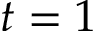Convert formula to latex. <formula><loc_0><loc_0><loc_500><loc_500>t = 1</formula> 